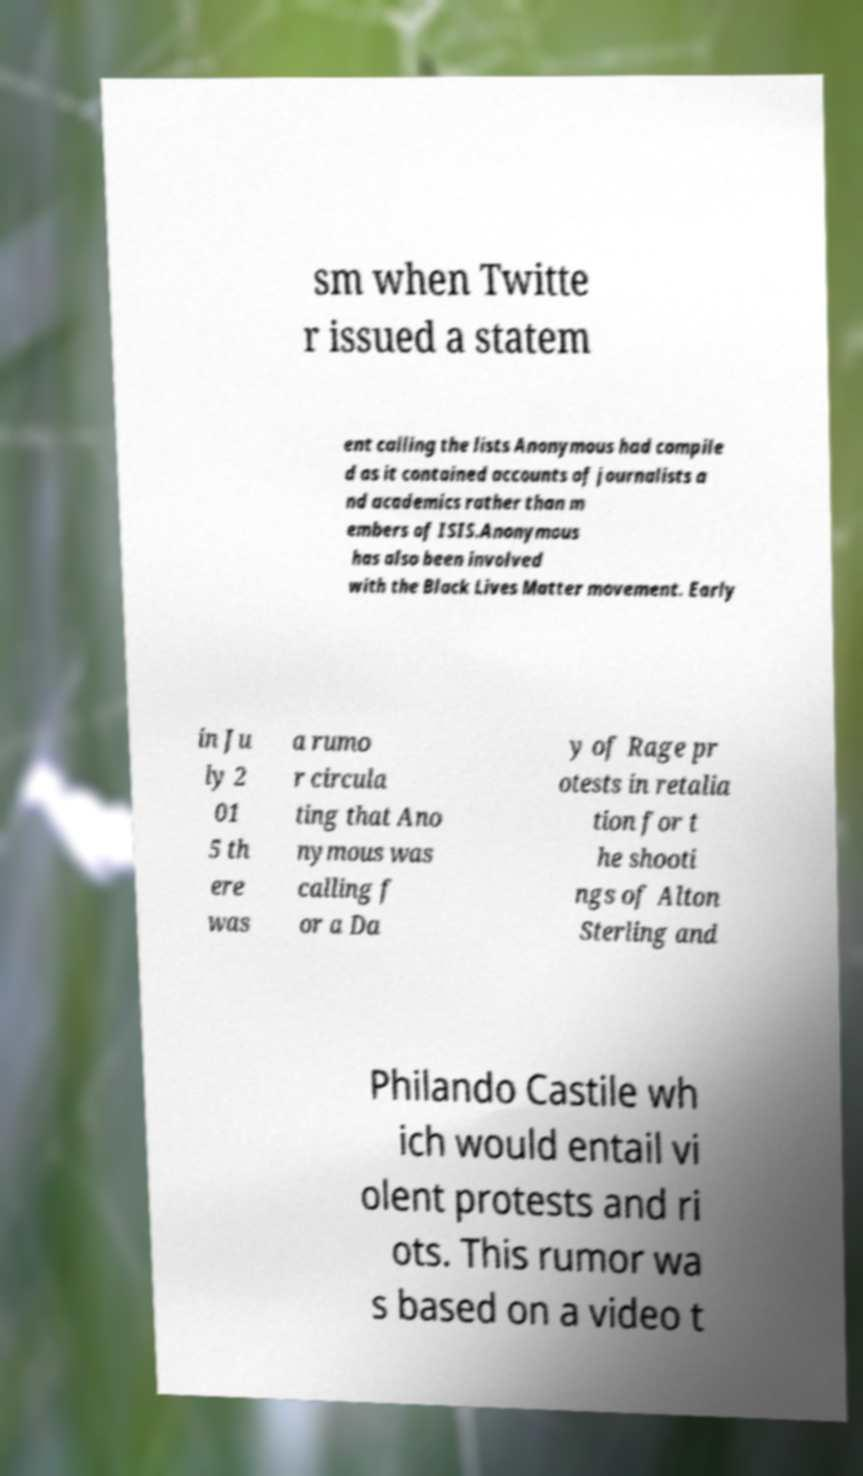What messages or text are displayed in this image? I need them in a readable, typed format. sm when Twitte r issued a statem ent calling the lists Anonymous had compile d as it contained accounts of journalists a nd academics rather than m embers of ISIS.Anonymous has also been involved with the Black Lives Matter movement. Early in Ju ly 2 01 5 th ere was a rumo r circula ting that Ano nymous was calling f or a Da y of Rage pr otests in retalia tion for t he shooti ngs of Alton Sterling and Philando Castile wh ich would entail vi olent protests and ri ots. This rumor wa s based on a video t 